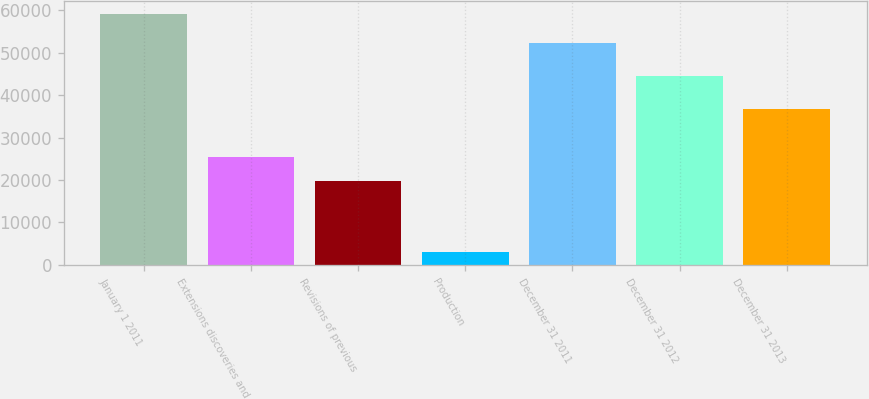Convert chart to OTSL. <chart><loc_0><loc_0><loc_500><loc_500><bar_chart><fcel>January 1 2011<fcel>Extensions discoveries and<fcel>Revisions of previous<fcel>Production<fcel>December 31 2011<fcel>December 31 2012<fcel>December 31 2013<nl><fcel>59195<fcel>25463.6<fcel>19841.7<fcel>2976<fcel>52391<fcel>44591<fcel>36707.4<nl></chart> 